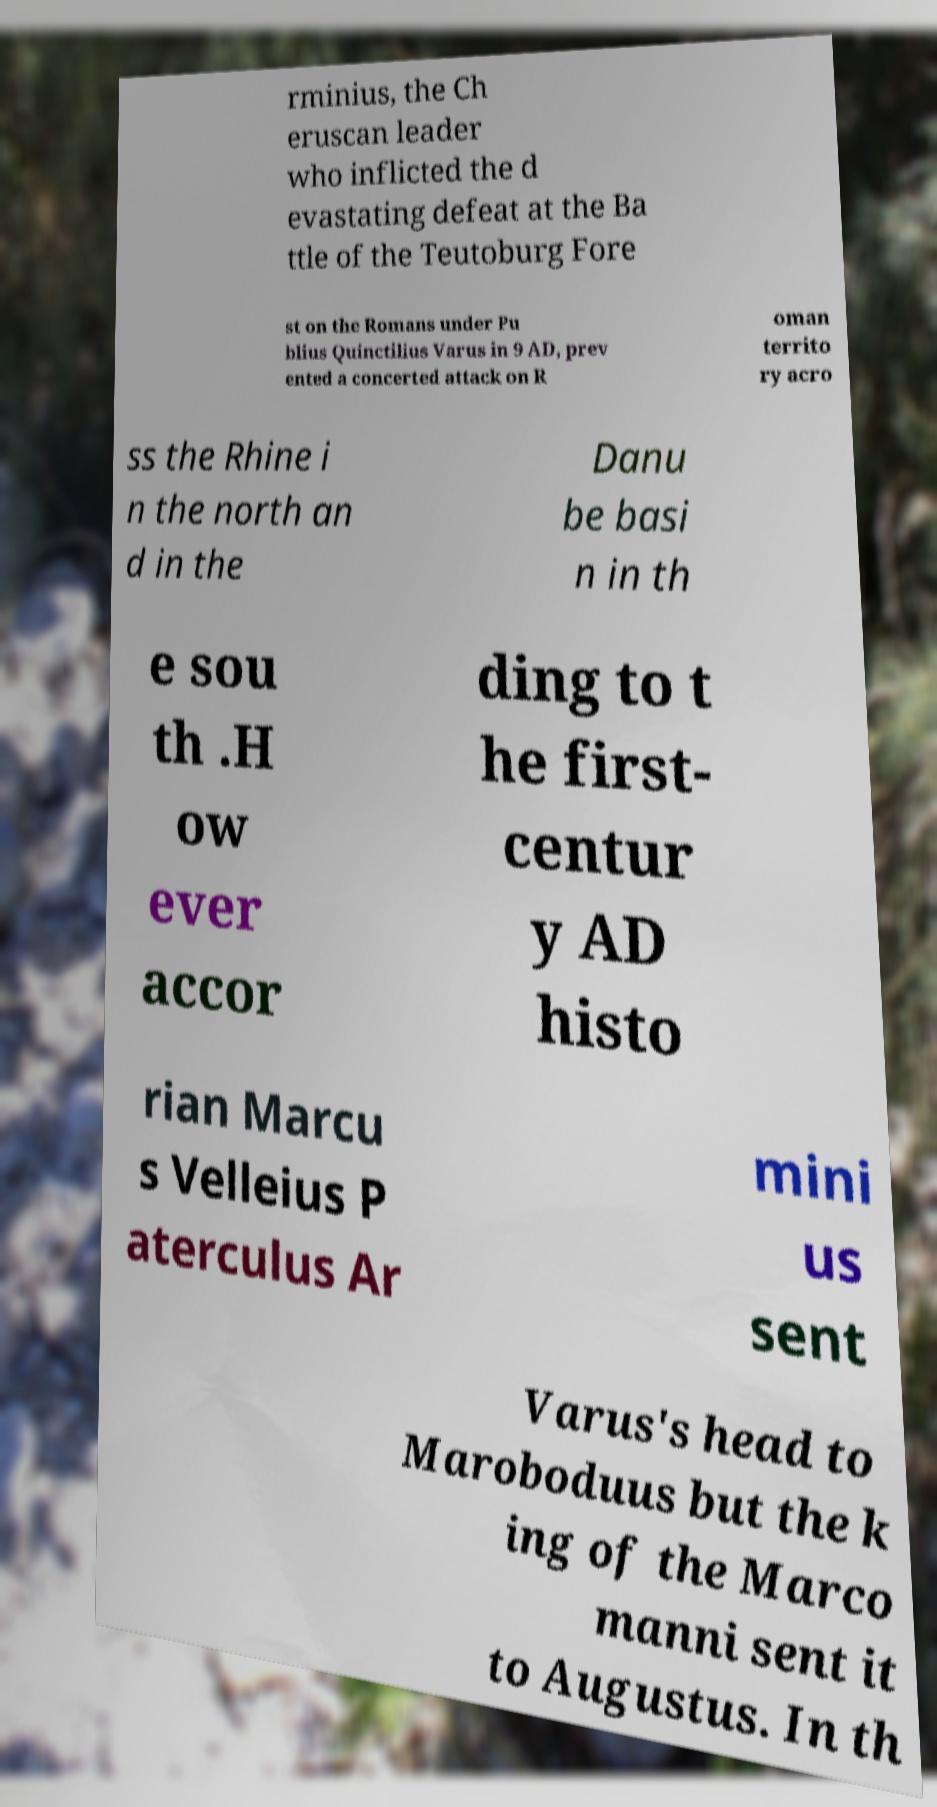Can you read and provide the text displayed in the image?This photo seems to have some interesting text. Can you extract and type it out for me? rminius, the Ch eruscan leader who inflicted the d evastating defeat at the Ba ttle of the Teutoburg Fore st on the Romans under Pu blius Quinctilius Varus in 9 AD, prev ented a concerted attack on R oman territo ry acro ss the Rhine i n the north an d in the Danu be basi n in th e sou th .H ow ever accor ding to t he first- centur y AD histo rian Marcu s Velleius P aterculus Ar mini us sent Varus's head to Maroboduus but the k ing of the Marco manni sent it to Augustus. In th 